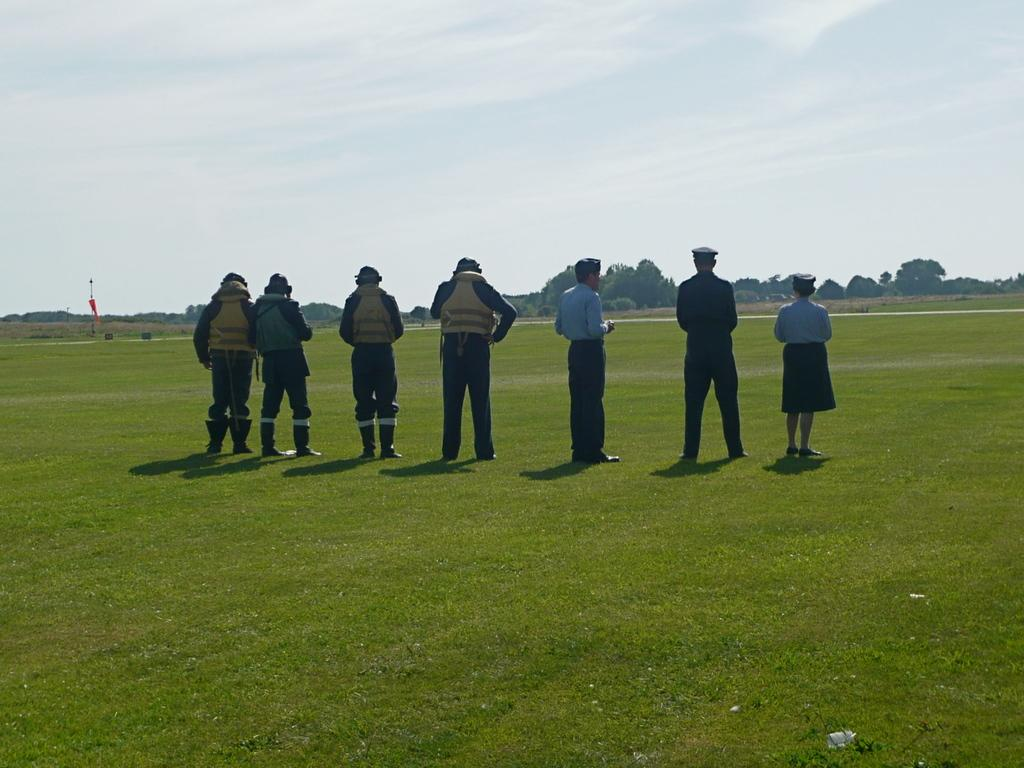What are the people in the image doing? The persons standing on the ground are likely observing or participating in an event. What can be seen in the background of the image? There is a pole with a flag on it, trees, and the sky visible in the background. What is the condition of the sky in the image? The sky is visible in the background, and clouds are present. What type of toothbrush is hanging from the flagpole in the image? There is no toothbrush present in the image. Who is the owner of the locket hanging from the tree in the image? There is no locket or indication of ownership in the image. 